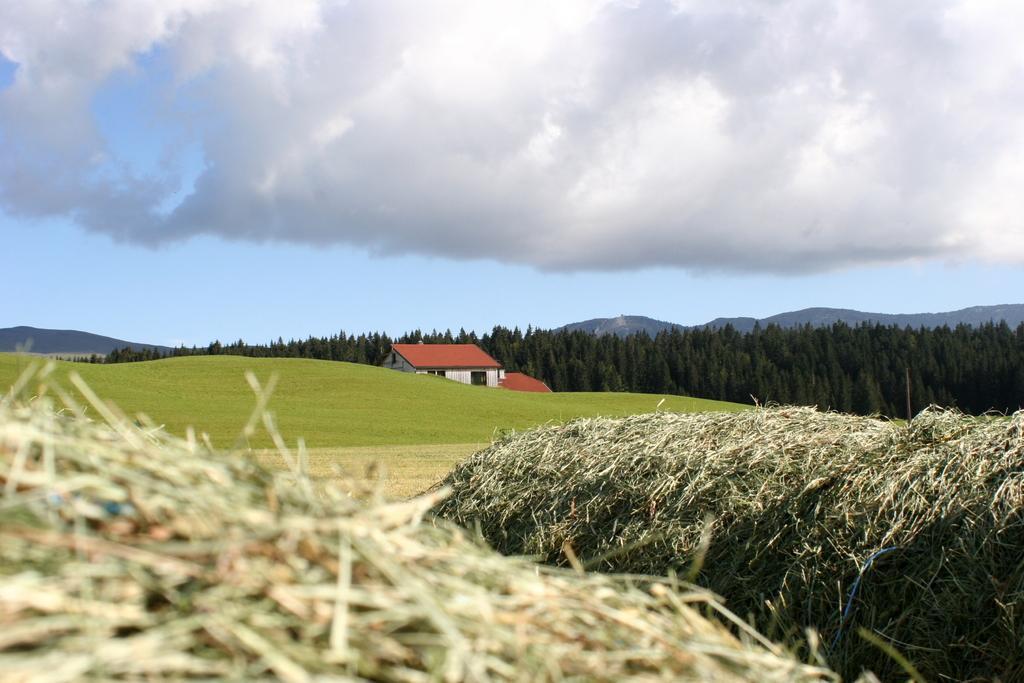Could you give a brief overview of what you see in this image? In this image we can see grass. In the back there is a grass lawn, house with windows, trees, hills and sky with clouds. 